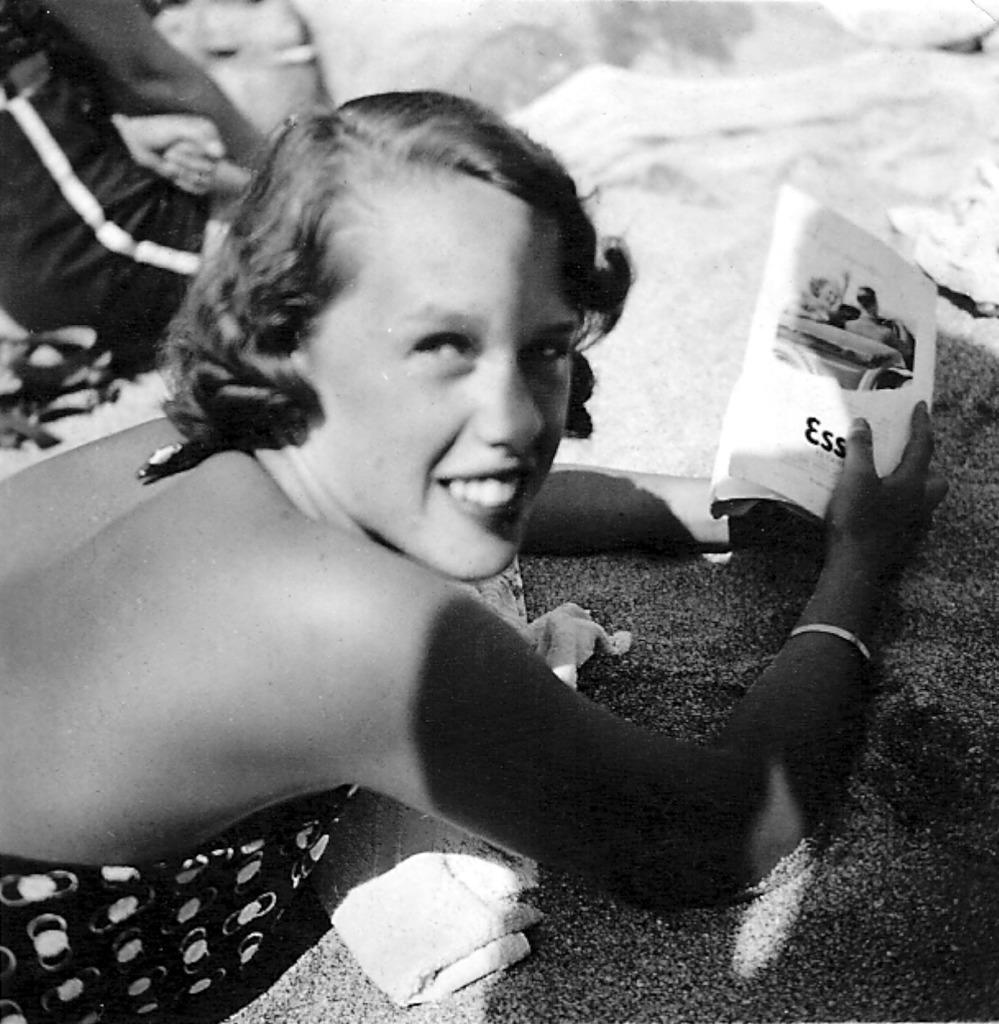Who is present in the image? There is a woman in the image. What is the woman holding in the image? The woman is holding a book. Where is the woman located in the image? The woman is lying on the sand. What type of cork can be seen in the woman's hair in the image? There is no cork present in the woman's hair or in the image. 